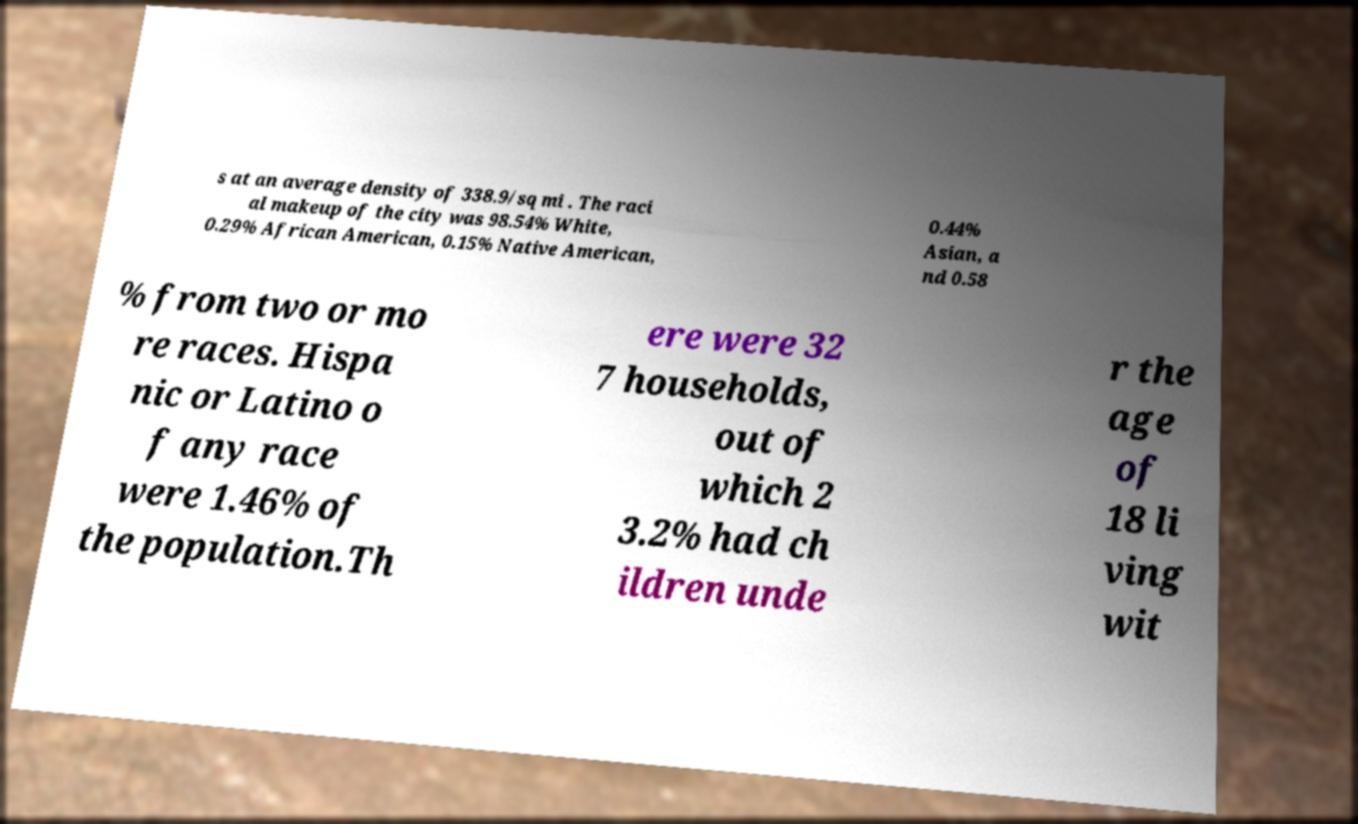Could you extract and type out the text from this image? s at an average density of 338.9/sq mi . The raci al makeup of the city was 98.54% White, 0.29% African American, 0.15% Native American, 0.44% Asian, a nd 0.58 % from two or mo re races. Hispa nic or Latino o f any race were 1.46% of the population.Th ere were 32 7 households, out of which 2 3.2% had ch ildren unde r the age of 18 li ving wit 